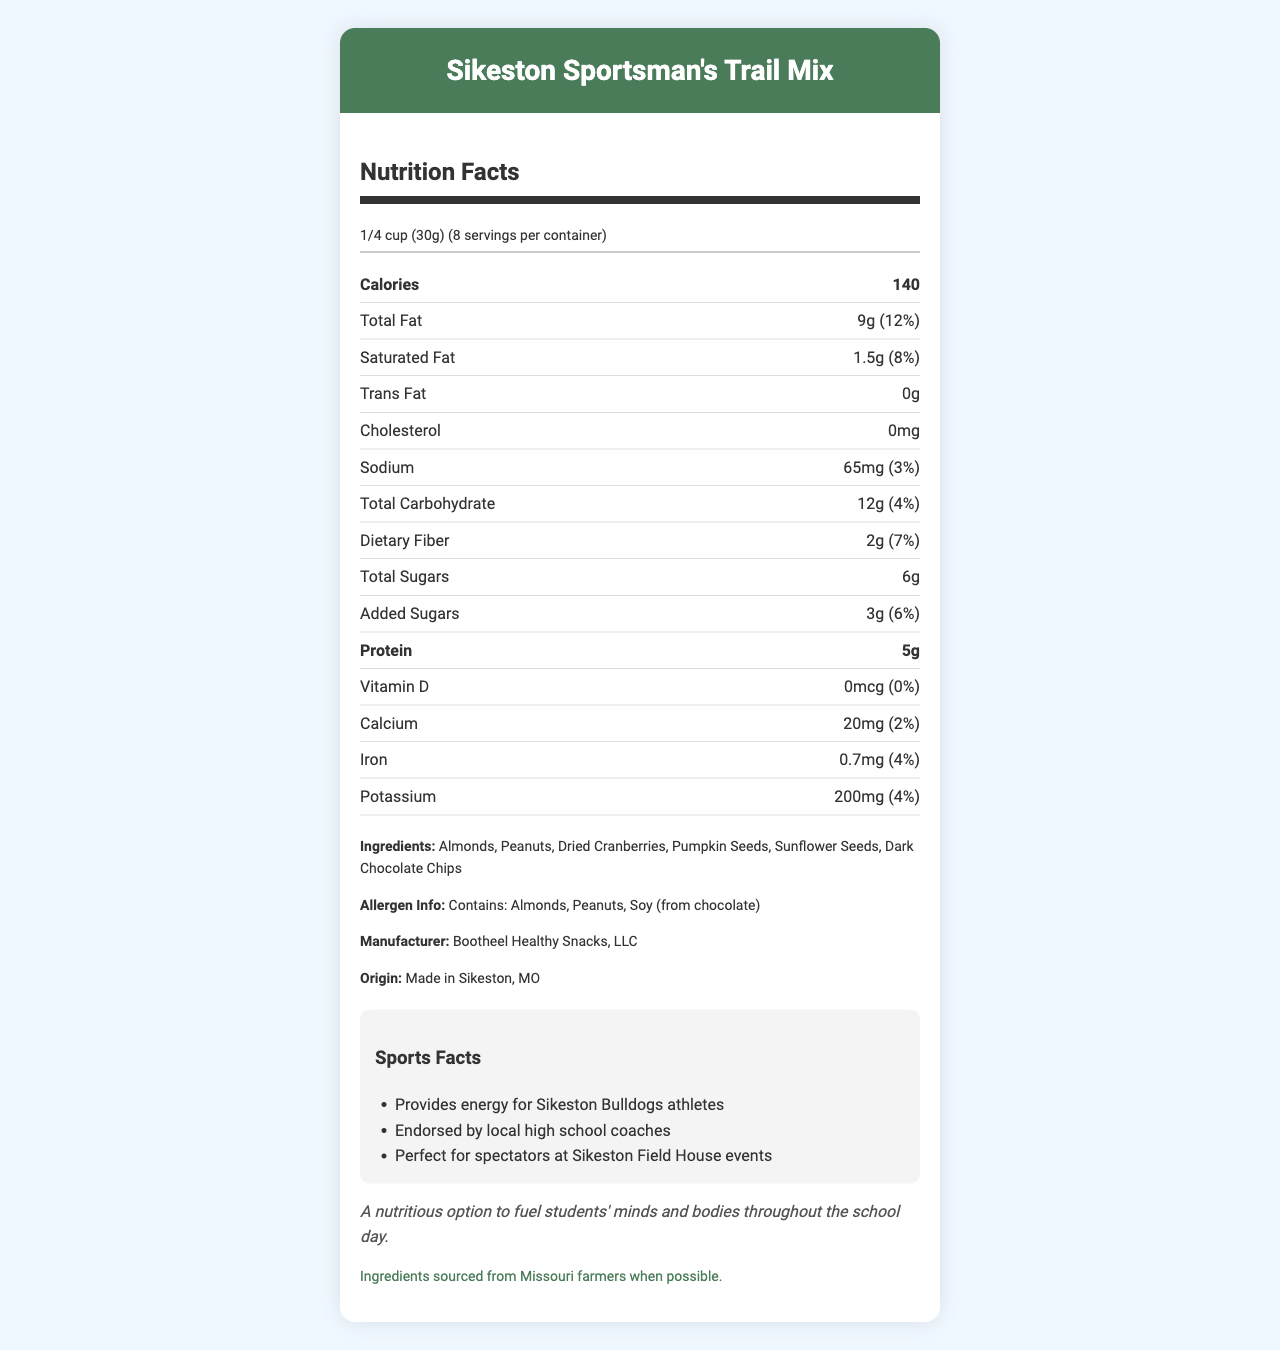what is the serving size for Sikeston Sportsman's Trail Mix? The serving size is listed at the beginning of the nutrition facts, indicating that each serving is 1/4 cup or 30 grams.
Answer: 1/4 cup (30g) how many calories are in each serving of the trail mix? The nutrition facts clearly state that there are 140 calories per serving.
Answer: 140 how much dietary fiber does each serving contain? Each serving contains 2 grams of dietary fiber as specified in the nutrition facts section.
Answer: 2g is there any trans fat in the Sikeston Sportsman's Trail Mix? The nutrition facts show that the trans fat content is 0 grams, meaning there is no trans fat in the trail mix.
Answer: No what is the total sugar content per serving? Each serving contains 6 grams of total sugars, as listed in the nutrition details.
Answer: 6g what are the ingredients in Sikeston Sportsman’s Trail Mix? The ingredients are listed towards the bottom of the nutrition facts, specifically stating these six items.
Answer: Almonds, Peanuts, Dried Cranberries, Pumpkin Seeds, Sunflower Seeds, Dark Chocolate Chips who manufactures the trail mix? A. Bootheel Healthy Snacks, LLC B. Sikeston Snacks Co. C. Missouri Munchies Corp. The document lists Bootheel Healthy Snacks, LLC as the manufacturer of the trail mix.
Answer: A what is the percentage of daily value for iron in each serving of the trail mix? A. 2% B. 4% C. 6% D. 8% The nutrition facts show that the iron content is 0.7mg, which corresponds to 4% of the daily value.
Answer: B does the trail mix contain any cholesterol? The document specifies that the cholesterol content is 0mg, meaning it does not contain any cholesterol.
Answer: No describe the allergen information for this product The allergen information is clearly stated in the ingredients section, detailing the allergens present in the mix.
Answer: Contains: Almonds, Peanuts, Soy (from chocolate) is the trail mix a good option to support local athletes? The sports facts mention that the trail mix provides energy for Sikeston Bulldogs athletes and is endorsed by local high school coaches, making it a good option.
Answer: Yes is there enough information to determine the exact serving size in grams? The serving size is specified as 1/4 cup (30g), providing exact measurements both in volume and weight.
Answer: Yes summarize the main benefits and purpose of Sikeston Sportsman’s Trail Mix The document emphasizes the nutritional value, local sourcing, and community support aspect, noting ingredients like nuts and seeds and their specific benefits for local athletes.
Answer: The Sikeston Sportsman's Trail Mix is a nutritious snack option made with local ingredients, designed to provide energy and support to students and athletes. It contains healthy fats, fiber, and proteins, sourced from almonds, peanuts, dried cranberries, pumpkin seeds, sunflower seeds, and dark chocolate chips. It's also endorsed by local high school coaches and suited for spectators at local sports events. how much protein does each serving of trail mix contain? The nutrition facts state that there are 5 grams of protein per serving.
Answer: 5g what is the school counselor's note about this product? The document includes this note at the bottom, reflecting the school counselor's endorsement of the product's nutritional benefits.
Answer: A nutritious option to fuel students' minds and bodies throughout the school day. which of the following is NOT listed as an ingredient in the trail mix? A. Almonds B. Cashew Nuts C. Peanuts D. Dried Cranberries The ingredients listed do not include cashew nuts, making option B the correct answer.
Answer: B 